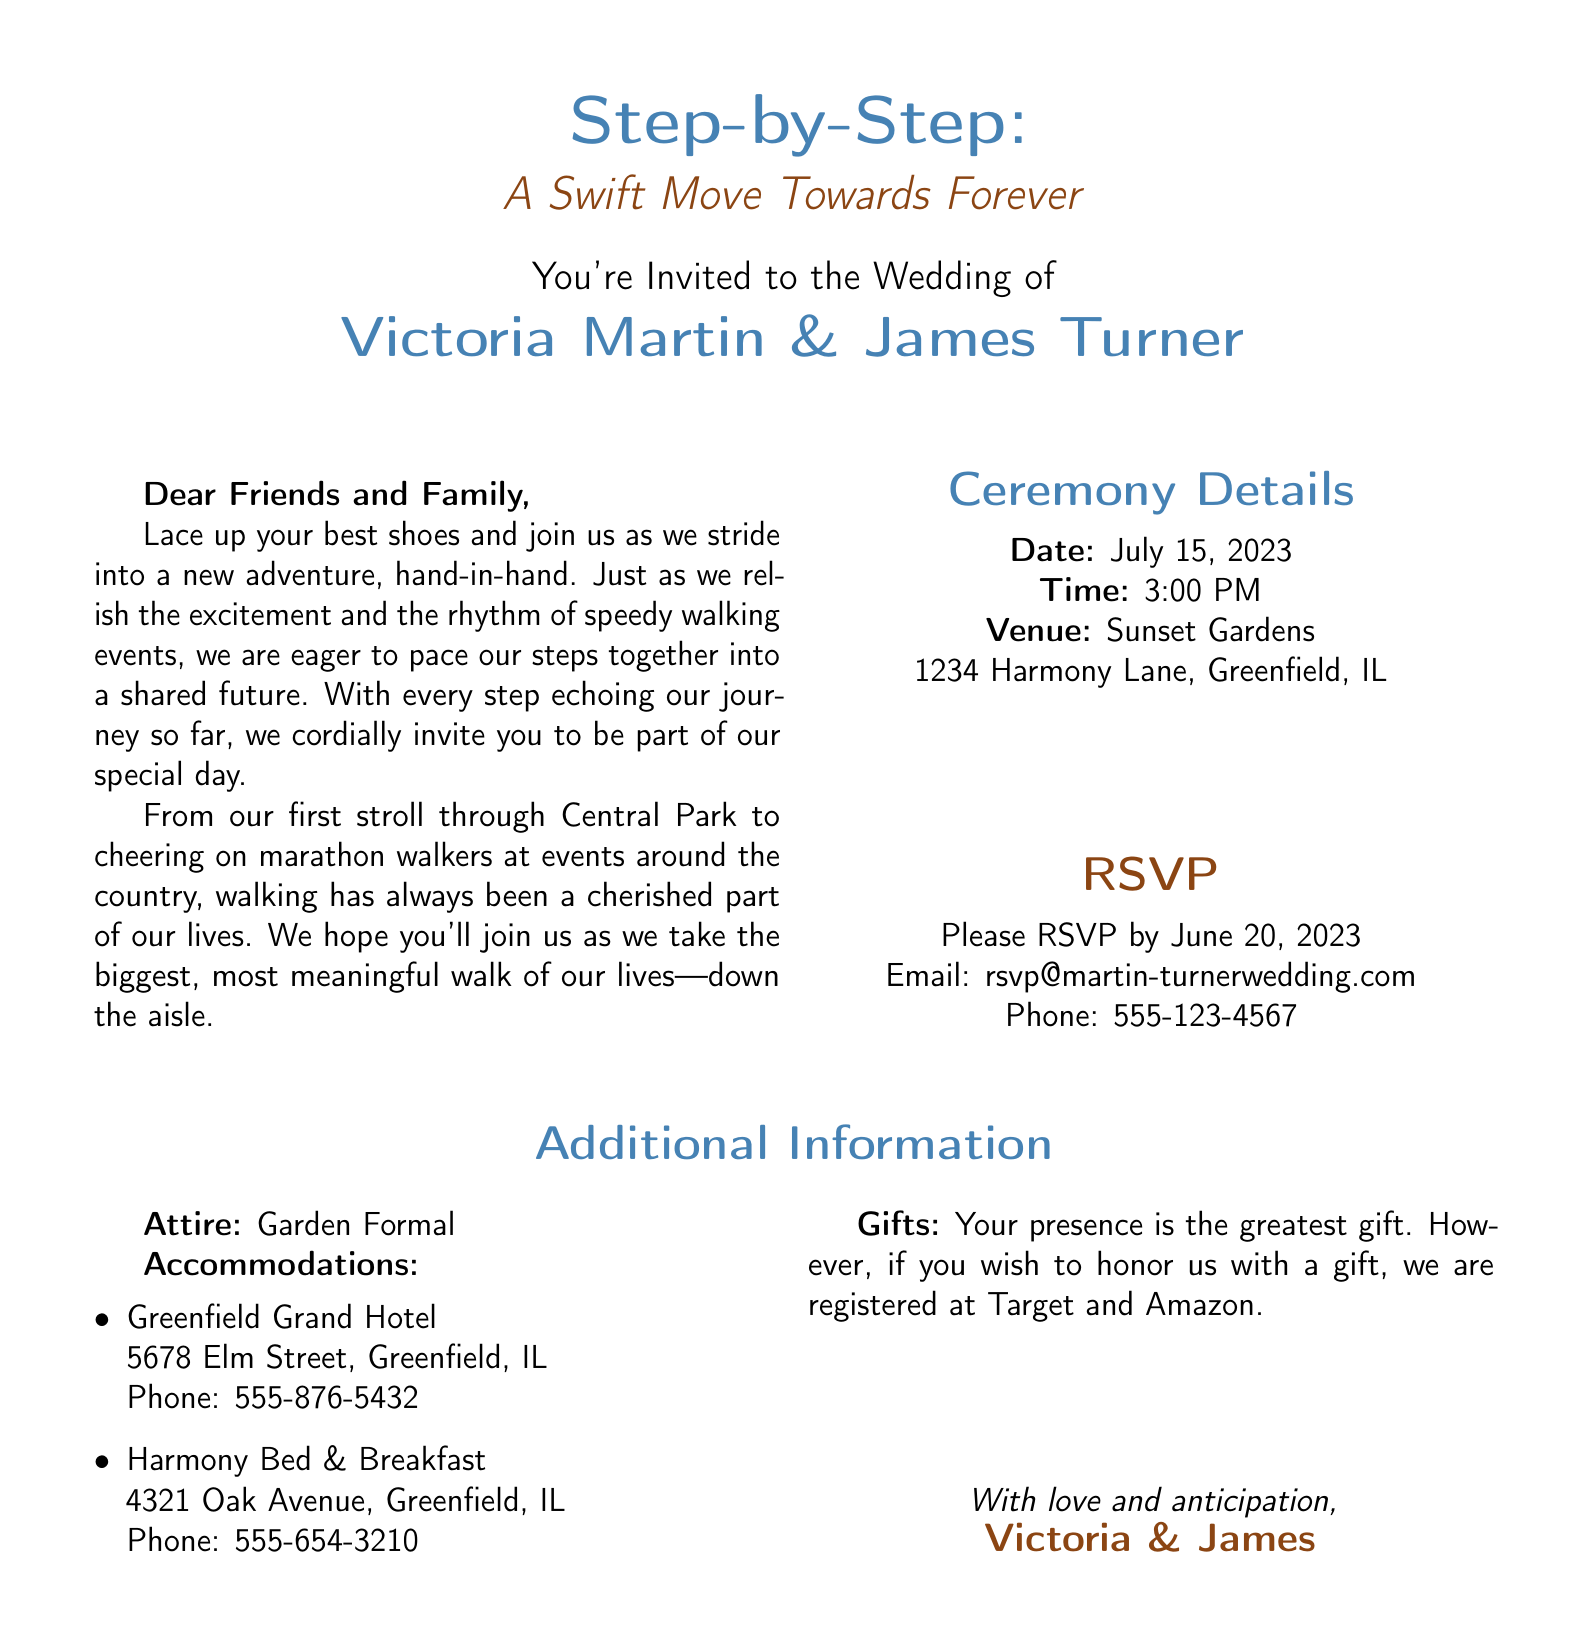what is the date of the wedding? The wedding date is explicitly mentioned in the ceremony details section of the document.
Answer: July 15, 2023 who are the bride and groom? The names of the bride and groom are stated prominently in the invitation.
Answer: Victoria Martin & James Turner what time does the ceremony start? The ceremony time is clearly listed in the document under ceremony details.
Answer: 3:00 PM where is the wedding venue located? The venue is detailed in the ceremony section of the invitation.
Answer: Sunset Gardens, 1234 Harmony Lane, Greenfield, IL what is the attire for the wedding? Dress code information is provided in the additional information section of the document.
Answer: Garden Formal by when should guests RSVP? The RSVP deadline is specified in the invitation.
Answer: June 20, 2023 what type of gifts are the couple registered for? The gifts information is mentioned in the document, outlining where guests can buy gifts for the couple.
Answer: Target and Amazon what is the phone number to RSVP? The phone number for RSVP inquiries is provided in the invitation.
Answer: 555-123-4567 